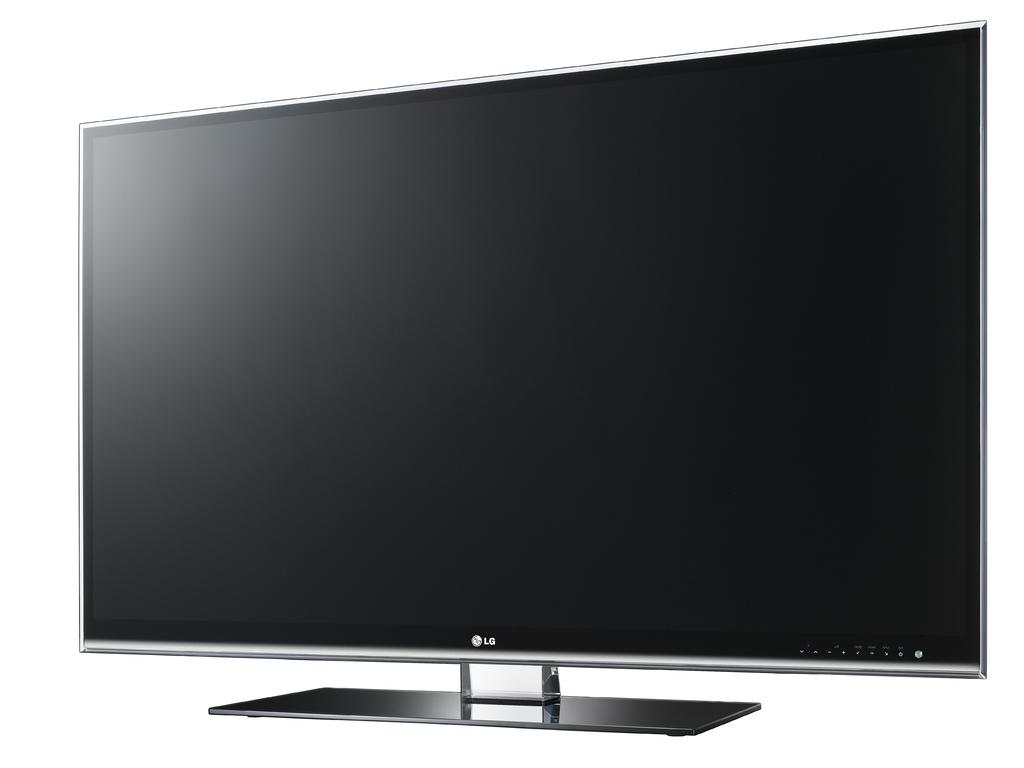<image>
Write a terse but informative summary of the picture. A large flat screen TV that says LG on the front. 